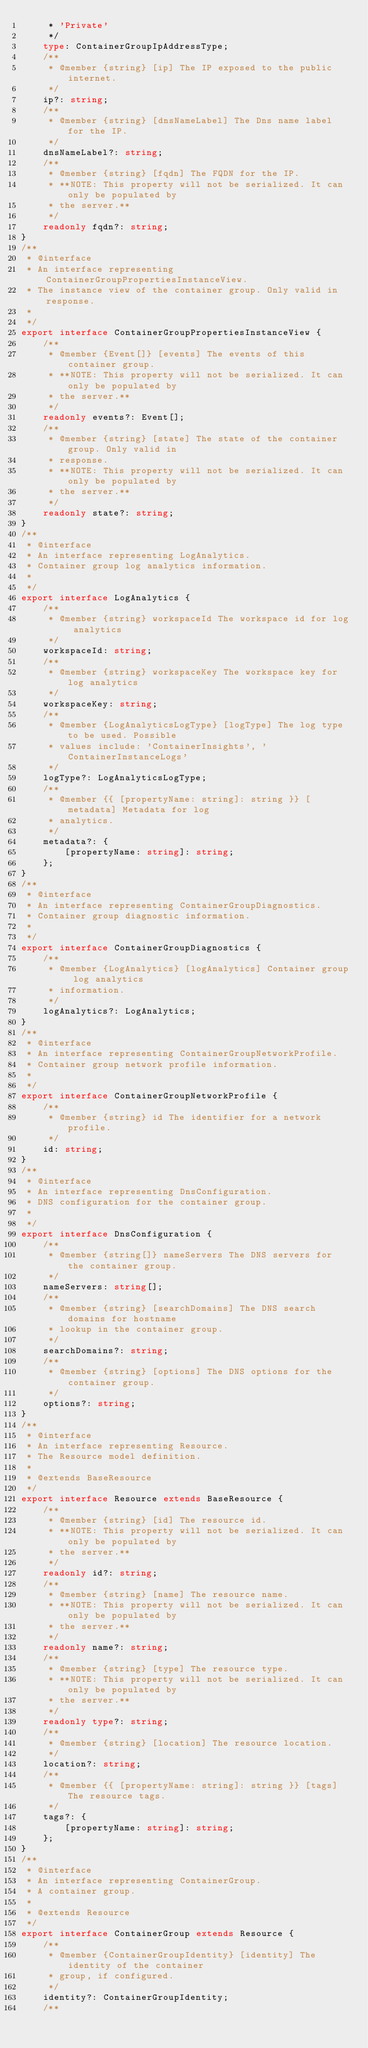Convert code to text. <code><loc_0><loc_0><loc_500><loc_500><_TypeScript_>     * 'Private'
     */
    type: ContainerGroupIpAddressType;
    /**
     * @member {string} [ip] The IP exposed to the public internet.
     */
    ip?: string;
    /**
     * @member {string} [dnsNameLabel] The Dns name label for the IP.
     */
    dnsNameLabel?: string;
    /**
     * @member {string} [fqdn] The FQDN for the IP.
     * **NOTE: This property will not be serialized. It can only be populated by
     * the server.**
     */
    readonly fqdn?: string;
}
/**
 * @interface
 * An interface representing ContainerGroupPropertiesInstanceView.
 * The instance view of the container group. Only valid in response.
 *
 */
export interface ContainerGroupPropertiesInstanceView {
    /**
     * @member {Event[]} [events] The events of this container group.
     * **NOTE: This property will not be serialized. It can only be populated by
     * the server.**
     */
    readonly events?: Event[];
    /**
     * @member {string} [state] The state of the container group. Only valid in
     * response.
     * **NOTE: This property will not be serialized. It can only be populated by
     * the server.**
     */
    readonly state?: string;
}
/**
 * @interface
 * An interface representing LogAnalytics.
 * Container group log analytics information.
 *
 */
export interface LogAnalytics {
    /**
     * @member {string} workspaceId The workspace id for log analytics
     */
    workspaceId: string;
    /**
     * @member {string} workspaceKey The workspace key for log analytics
     */
    workspaceKey: string;
    /**
     * @member {LogAnalyticsLogType} [logType] The log type to be used. Possible
     * values include: 'ContainerInsights', 'ContainerInstanceLogs'
     */
    logType?: LogAnalyticsLogType;
    /**
     * @member {{ [propertyName: string]: string }} [metadata] Metadata for log
     * analytics.
     */
    metadata?: {
        [propertyName: string]: string;
    };
}
/**
 * @interface
 * An interface representing ContainerGroupDiagnostics.
 * Container group diagnostic information.
 *
 */
export interface ContainerGroupDiagnostics {
    /**
     * @member {LogAnalytics} [logAnalytics] Container group log analytics
     * information.
     */
    logAnalytics?: LogAnalytics;
}
/**
 * @interface
 * An interface representing ContainerGroupNetworkProfile.
 * Container group network profile information.
 *
 */
export interface ContainerGroupNetworkProfile {
    /**
     * @member {string} id The identifier for a network profile.
     */
    id: string;
}
/**
 * @interface
 * An interface representing DnsConfiguration.
 * DNS configuration for the container group.
 *
 */
export interface DnsConfiguration {
    /**
     * @member {string[]} nameServers The DNS servers for the container group.
     */
    nameServers: string[];
    /**
     * @member {string} [searchDomains] The DNS search domains for hostname
     * lookup in the container group.
     */
    searchDomains?: string;
    /**
     * @member {string} [options] The DNS options for the container group.
     */
    options?: string;
}
/**
 * @interface
 * An interface representing Resource.
 * The Resource model definition.
 *
 * @extends BaseResource
 */
export interface Resource extends BaseResource {
    /**
     * @member {string} [id] The resource id.
     * **NOTE: This property will not be serialized. It can only be populated by
     * the server.**
     */
    readonly id?: string;
    /**
     * @member {string} [name] The resource name.
     * **NOTE: This property will not be serialized. It can only be populated by
     * the server.**
     */
    readonly name?: string;
    /**
     * @member {string} [type] The resource type.
     * **NOTE: This property will not be serialized. It can only be populated by
     * the server.**
     */
    readonly type?: string;
    /**
     * @member {string} [location] The resource location.
     */
    location?: string;
    /**
     * @member {{ [propertyName: string]: string }} [tags] The resource tags.
     */
    tags?: {
        [propertyName: string]: string;
    };
}
/**
 * @interface
 * An interface representing ContainerGroup.
 * A container group.
 *
 * @extends Resource
 */
export interface ContainerGroup extends Resource {
    /**
     * @member {ContainerGroupIdentity} [identity] The identity of the container
     * group, if configured.
     */
    identity?: ContainerGroupIdentity;
    /**</code> 